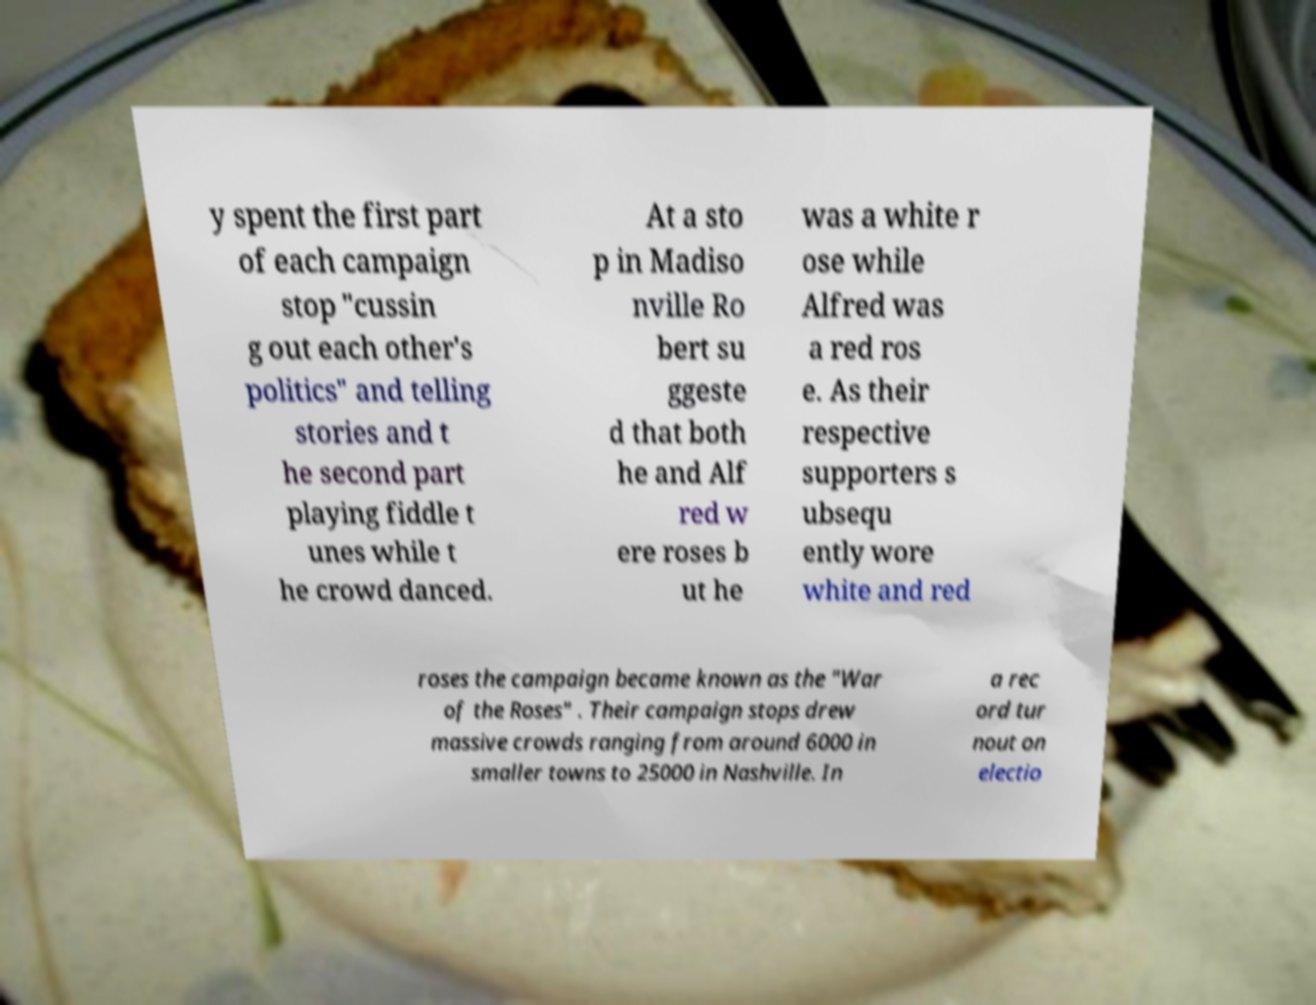I need the written content from this picture converted into text. Can you do that? y spent the first part of each campaign stop "cussin g out each other's politics" and telling stories and t he second part playing fiddle t unes while t he crowd danced. At a sto p in Madiso nville Ro bert su ggeste d that both he and Alf red w ere roses b ut he was a white r ose while Alfred was a red ros e. As their respective supporters s ubsequ ently wore white and red roses the campaign became known as the "War of the Roses" . Their campaign stops drew massive crowds ranging from around 6000 in smaller towns to 25000 in Nashville. In a rec ord tur nout on electio 